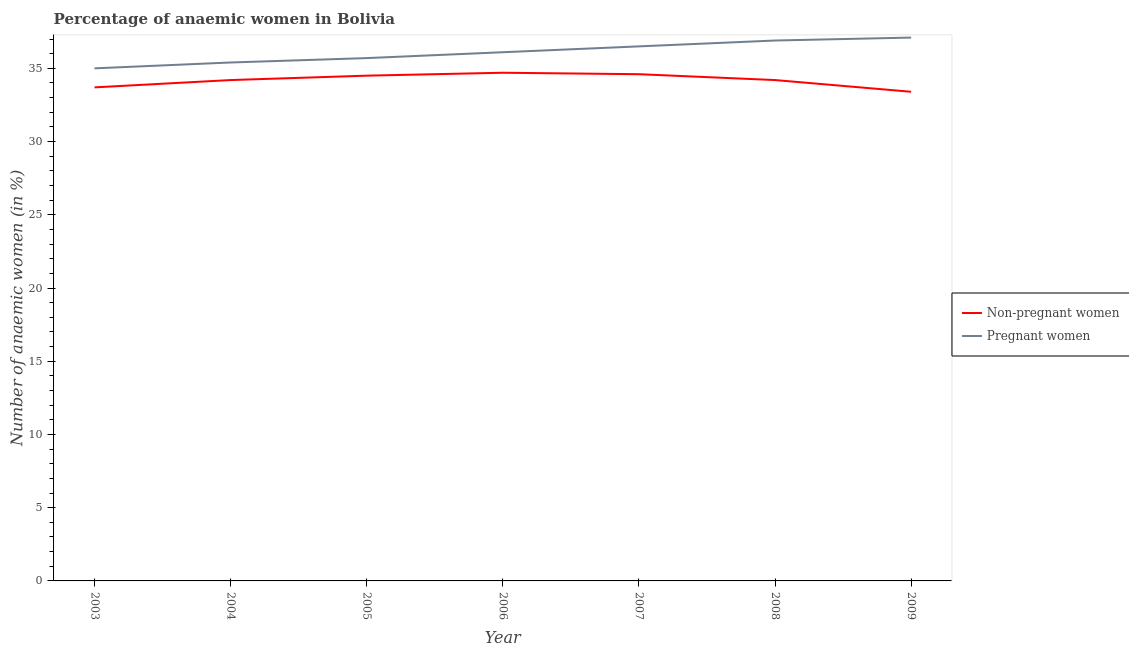How many different coloured lines are there?
Provide a short and direct response. 2. Does the line corresponding to percentage of pregnant anaemic women intersect with the line corresponding to percentage of non-pregnant anaemic women?
Give a very brief answer. No. What is the percentage of non-pregnant anaemic women in 2005?
Provide a short and direct response. 34.5. Across all years, what is the maximum percentage of pregnant anaemic women?
Your answer should be very brief. 37.1. Across all years, what is the minimum percentage of non-pregnant anaemic women?
Your response must be concise. 33.4. What is the total percentage of pregnant anaemic women in the graph?
Make the answer very short. 252.7. What is the difference between the percentage of pregnant anaemic women in 2003 and that in 2004?
Offer a terse response. -0.4. What is the difference between the percentage of non-pregnant anaemic women in 2004 and the percentage of pregnant anaemic women in 2008?
Your answer should be very brief. -2.7. What is the average percentage of non-pregnant anaemic women per year?
Give a very brief answer. 34.19. In the year 2009, what is the difference between the percentage of pregnant anaemic women and percentage of non-pregnant anaemic women?
Give a very brief answer. 3.7. In how many years, is the percentage of pregnant anaemic women greater than 15 %?
Your answer should be very brief. 7. What is the ratio of the percentage of non-pregnant anaemic women in 2006 to that in 2009?
Offer a terse response. 1.04. Is the percentage of pregnant anaemic women in 2004 less than that in 2006?
Keep it short and to the point. Yes. Is the difference between the percentage of pregnant anaemic women in 2007 and 2009 greater than the difference between the percentage of non-pregnant anaemic women in 2007 and 2009?
Offer a terse response. No. What is the difference between the highest and the second highest percentage of pregnant anaemic women?
Offer a very short reply. 0.2. What is the difference between the highest and the lowest percentage of pregnant anaemic women?
Provide a short and direct response. 2.1. Is the sum of the percentage of non-pregnant anaemic women in 2004 and 2008 greater than the maximum percentage of pregnant anaemic women across all years?
Keep it short and to the point. Yes. Does the percentage of pregnant anaemic women monotonically increase over the years?
Your answer should be compact. Yes. How many lines are there?
Offer a very short reply. 2. How many years are there in the graph?
Make the answer very short. 7. Are the values on the major ticks of Y-axis written in scientific E-notation?
Provide a succinct answer. No. Does the graph contain any zero values?
Offer a very short reply. No. Does the graph contain grids?
Ensure brevity in your answer.  No. Where does the legend appear in the graph?
Keep it short and to the point. Center right. How many legend labels are there?
Make the answer very short. 2. How are the legend labels stacked?
Your response must be concise. Vertical. What is the title of the graph?
Your answer should be very brief. Percentage of anaemic women in Bolivia. What is the label or title of the Y-axis?
Make the answer very short. Number of anaemic women (in %). What is the Number of anaemic women (in %) in Non-pregnant women in 2003?
Keep it short and to the point. 33.7. What is the Number of anaemic women (in %) of Non-pregnant women in 2004?
Give a very brief answer. 34.2. What is the Number of anaemic women (in %) of Pregnant women in 2004?
Your answer should be very brief. 35.4. What is the Number of anaemic women (in %) in Non-pregnant women in 2005?
Offer a very short reply. 34.5. What is the Number of anaemic women (in %) of Pregnant women in 2005?
Your answer should be very brief. 35.7. What is the Number of anaemic women (in %) of Non-pregnant women in 2006?
Your answer should be very brief. 34.7. What is the Number of anaemic women (in %) in Pregnant women in 2006?
Give a very brief answer. 36.1. What is the Number of anaemic women (in %) in Non-pregnant women in 2007?
Your answer should be very brief. 34.6. What is the Number of anaemic women (in %) in Pregnant women in 2007?
Make the answer very short. 36.5. What is the Number of anaemic women (in %) of Non-pregnant women in 2008?
Provide a short and direct response. 34.2. What is the Number of anaemic women (in %) in Pregnant women in 2008?
Keep it short and to the point. 36.9. What is the Number of anaemic women (in %) in Non-pregnant women in 2009?
Provide a succinct answer. 33.4. What is the Number of anaemic women (in %) of Pregnant women in 2009?
Offer a terse response. 37.1. Across all years, what is the maximum Number of anaemic women (in %) of Non-pregnant women?
Ensure brevity in your answer.  34.7. Across all years, what is the maximum Number of anaemic women (in %) of Pregnant women?
Your answer should be very brief. 37.1. Across all years, what is the minimum Number of anaemic women (in %) in Non-pregnant women?
Your response must be concise. 33.4. Across all years, what is the minimum Number of anaemic women (in %) in Pregnant women?
Keep it short and to the point. 35. What is the total Number of anaemic women (in %) in Non-pregnant women in the graph?
Give a very brief answer. 239.3. What is the total Number of anaemic women (in %) of Pregnant women in the graph?
Offer a very short reply. 252.7. What is the difference between the Number of anaemic women (in %) in Non-pregnant women in 2003 and that in 2004?
Ensure brevity in your answer.  -0.5. What is the difference between the Number of anaemic women (in %) in Non-pregnant women in 2003 and that in 2006?
Ensure brevity in your answer.  -1. What is the difference between the Number of anaemic women (in %) of Non-pregnant women in 2003 and that in 2007?
Provide a short and direct response. -0.9. What is the difference between the Number of anaemic women (in %) in Pregnant women in 2003 and that in 2007?
Provide a short and direct response. -1.5. What is the difference between the Number of anaemic women (in %) of Non-pregnant women in 2003 and that in 2008?
Provide a short and direct response. -0.5. What is the difference between the Number of anaemic women (in %) in Pregnant women in 2003 and that in 2009?
Ensure brevity in your answer.  -2.1. What is the difference between the Number of anaemic women (in %) of Non-pregnant women in 2004 and that in 2005?
Offer a very short reply. -0.3. What is the difference between the Number of anaemic women (in %) of Pregnant women in 2004 and that in 2006?
Offer a terse response. -0.7. What is the difference between the Number of anaemic women (in %) in Non-pregnant women in 2004 and that in 2009?
Your answer should be compact. 0.8. What is the difference between the Number of anaemic women (in %) of Non-pregnant women in 2005 and that in 2006?
Offer a very short reply. -0.2. What is the difference between the Number of anaemic women (in %) of Non-pregnant women in 2005 and that in 2008?
Offer a terse response. 0.3. What is the difference between the Number of anaemic women (in %) of Pregnant women in 2005 and that in 2008?
Make the answer very short. -1.2. What is the difference between the Number of anaemic women (in %) of Non-pregnant women in 2005 and that in 2009?
Provide a succinct answer. 1.1. What is the difference between the Number of anaemic women (in %) in Pregnant women in 2005 and that in 2009?
Your answer should be very brief. -1.4. What is the difference between the Number of anaemic women (in %) of Pregnant women in 2006 and that in 2008?
Offer a very short reply. -0.8. What is the difference between the Number of anaemic women (in %) in Non-pregnant women in 2007 and that in 2008?
Offer a terse response. 0.4. What is the difference between the Number of anaemic women (in %) in Pregnant women in 2007 and that in 2008?
Your answer should be compact. -0.4. What is the difference between the Number of anaemic women (in %) in Pregnant women in 2007 and that in 2009?
Make the answer very short. -0.6. What is the difference between the Number of anaemic women (in %) in Non-pregnant women in 2008 and that in 2009?
Give a very brief answer. 0.8. What is the difference between the Number of anaemic women (in %) of Pregnant women in 2008 and that in 2009?
Make the answer very short. -0.2. What is the difference between the Number of anaemic women (in %) of Non-pregnant women in 2003 and the Number of anaemic women (in %) of Pregnant women in 2004?
Offer a terse response. -1.7. What is the difference between the Number of anaemic women (in %) of Non-pregnant women in 2003 and the Number of anaemic women (in %) of Pregnant women in 2006?
Provide a succinct answer. -2.4. What is the difference between the Number of anaemic women (in %) in Non-pregnant women in 2003 and the Number of anaemic women (in %) in Pregnant women in 2008?
Keep it short and to the point. -3.2. What is the difference between the Number of anaemic women (in %) in Non-pregnant women in 2003 and the Number of anaemic women (in %) in Pregnant women in 2009?
Your response must be concise. -3.4. What is the difference between the Number of anaemic women (in %) in Non-pregnant women in 2004 and the Number of anaemic women (in %) in Pregnant women in 2006?
Provide a short and direct response. -1.9. What is the difference between the Number of anaemic women (in %) in Non-pregnant women in 2004 and the Number of anaemic women (in %) in Pregnant women in 2008?
Provide a short and direct response. -2.7. What is the difference between the Number of anaemic women (in %) in Non-pregnant women in 2004 and the Number of anaemic women (in %) in Pregnant women in 2009?
Your answer should be compact. -2.9. What is the difference between the Number of anaemic women (in %) of Non-pregnant women in 2005 and the Number of anaemic women (in %) of Pregnant women in 2006?
Offer a very short reply. -1.6. What is the difference between the Number of anaemic women (in %) in Non-pregnant women in 2005 and the Number of anaemic women (in %) in Pregnant women in 2008?
Give a very brief answer. -2.4. What is the difference between the Number of anaemic women (in %) of Non-pregnant women in 2006 and the Number of anaemic women (in %) of Pregnant women in 2007?
Make the answer very short. -1.8. What is the difference between the Number of anaemic women (in %) of Non-pregnant women in 2007 and the Number of anaemic women (in %) of Pregnant women in 2008?
Keep it short and to the point. -2.3. What is the difference between the Number of anaemic women (in %) in Non-pregnant women in 2007 and the Number of anaemic women (in %) in Pregnant women in 2009?
Your answer should be compact. -2.5. What is the difference between the Number of anaemic women (in %) in Non-pregnant women in 2008 and the Number of anaemic women (in %) in Pregnant women in 2009?
Your answer should be compact. -2.9. What is the average Number of anaemic women (in %) in Non-pregnant women per year?
Your answer should be very brief. 34.19. What is the average Number of anaemic women (in %) of Pregnant women per year?
Your response must be concise. 36.1. In the year 2003, what is the difference between the Number of anaemic women (in %) in Non-pregnant women and Number of anaemic women (in %) in Pregnant women?
Ensure brevity in your answer.  -1.3. In the year 2006, what is the difference between the Number of anaemic women (in %) in Non-pregnant women and Number of anaemic women (in %) in Pregnant women?
Ensure brevity in your answer.  -1.4. In the year 2008, what is the difference between the Number of anaemic women (in %) of Non-pregnant women and Number of anaemic women (in %) of Pregnant women?
Your response must be concise. -2.7. What is the ratio of the Number of anaemic women (in %) of Non-pregnant women in 2003 to that in 2004?
Keep it short and to the point. 0.99. What is the ratio of the Number of anaemic women (in %) in Pregnant women in 2003 to that in 2004?
Offer a very short reply. 0.99. What is the ratio of the Number of anaemic women (in %) in Non-pregnant women in 2003 to that in 2005?
Offer a very short reply. 0.98. What is the ratio of the Number of anaemic women (in %) in Pregnant women in 2003 to that in 2005?
Offer a terse response. 0.98. What is the ratio of the Number of anaemic women (in %) in Non-pregnant women in 2003 to that in 2006?
Your answer should be compact. 0.97. What is the ratio of the Number of anaemic women (in %) of Pregnant women in 2003 to that in 2006?
Provide a short and direct response. 0.97. What is the ratio of the Number of anaemic women (in %) in Non-pregnant women in 2003 to that in 2007?
Your response must be concise. 0.97. What is the ratio of the Number of anaemic women (in %) in Pregnant women in 2003 to that in 2007?
Ensure brevity in your answer.  0.96. What is the ratio of the Number of anaemic women (in %) of Non-pregnant women in 2003 to that in 2008?
Your answer should be very brief. 0.99. What is the ratio of the Number of anaemic women (in %) of Pregnant women in 2003 to that in 2008?
Provide a short and direct response. 0.95. What is the ratio of the Number of anaemic women (in %) in Non-pregnant women in 2003 to that in 2009?
Your response must be concise. 1.01. What is the ratio of the Number of anaemic women (in %) of Pregnant women in 2003 to that in 2009?
Your answer should be very brief. 0.94. What is the ratio of the Number of anaemic women (in %) in Non-pregnant women in 2004 to that in 2005?
Make the answer very short. 0.99. What is the ratio of the Number of anaemic women (in %) in Pregnant women in 2004 to that in 2005?
Provide a short and direct response. 0.99. What is the ratio of the Number of anaemic women (in %) in Non-pregnant women in 2004 to that in 2006?
Provide a succinct answer. 0.99. What is the ratio of the Number of anaemic women (in %) in Pregnant women in 2004 to that in 2006?
Keep it short and to the point. 0.98. What is the ratio of the Number of anaemic women (in %) in Non-pregnant women in 2004 to that in 2007?
Provide a succinct answer. 0.99. What is the ratio of the Number of anaemic women (in %) in Pregnant women in 2004 to that in 2007?
Your answer should be very brief. 0.97. What is the ratio of the Number of anaemic women (in %) in Pregnant women in 2004 to that in 2008?
Give a very brief answer. 0.96. What is the ratio of the Number of anaemic women (in %) of Non-pregnant women in 2004 to that in 2009?
Offer a terse response. 1.02. What is the ratio of the Number of anaemic women (in %) of Pregnant women in 2004 to that in 2009?
Keep it short and to the point. 0.95. What is the ratio of the Number of anaemic women (in %) in Non-pregnant women in 2005 to that in 2006?
Make the answer very short. 0.99. What is the ratio of the Number of anaemic women (in %) of Pregnant women in 2005 to that in 2006?
Your response must be concise. 0.99. What is the ratio of the Number of anaemic women (in %) in Pregnant women in 2005 to that in 2007?
Give a very brief answer. 0.98. What is the ratio of the Number of anaemic women (in %) in Non-pregnant women in 2005 to that in 2008?
Ensure brevity in your answer.  1.01. What is the ratio of the Number of anaemic women (in %) of Pregnant women in 2005 to that in 2008?
Your response must be concise. 0.97. What is the ratio of the Number of anaemic women (in %) of Non-pregnant women in 2005 to that in 2009?
Your answer should be very brief. 1.03. What is the ratio of the Number of anaemic women (in %) in Pregnant women in 2005 to that in 2009?
Keep it short and to the point. 0.96. What is the ratio of the Number of anaemic women (in %) in Non-pregnant women in 2006 to that in 2007?
Your answer should be very brief. 1. What is the ratio of the Number of anaemic women (in %) of Pregnant women in 2006 to that in 2007?
Provide a succinct answer. 0.99. What is the ratio of the Number of anaemic women (in %) of Non-pregnant women in 2006 to that in 2008?
Make the answer very short. 1.01. What is the ratio of the Number of anaemic women (in %) in Pregnant women in 2006 to that in 2008?
Offer a very short reply. 0.98. What is the ratio of the Number of anaemic women (in %) in Non-pregnant women in 2006 to that in 2009?
Provide a succinct answer. 1.04. What is the ratio of the Number of anaemic women (in %) of Non-pregnant women in 2007 to that in 2008?
Provide a short and direct response. 1.01. What is the ratio of the Number of anaemic women (in %) of Non-pregnant women in 2007 to that in 2009?
Give a very brief answer. 1.04. What is the ratio of the Number of anaemic women (in %) of Pregnant women in 2007 to that in 2009?
Make the answer very short. 0.98. What is the ratio of the Number of anaemic women (in %) in Pregnant women in 2008 to that in 2009?
Offer a terse response. 0.99. 